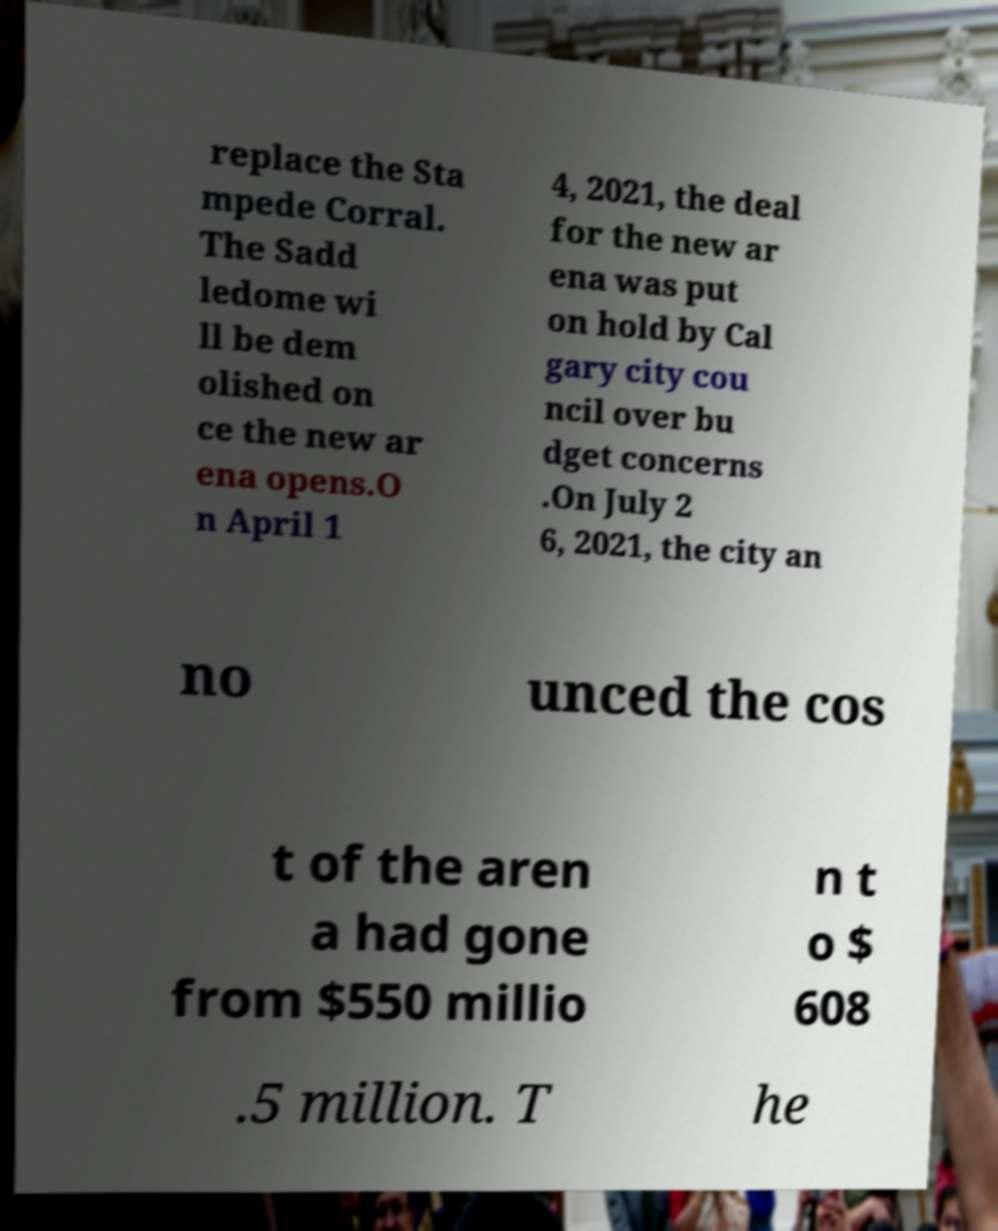There's text embedded in this image that I need extracted. Can you transcribe it verbatim? replace the Sta mpede Corral. The Sadd ledome wi ll be dem olished on ce the new ar ena opens.O n April 1 4, 2021, the deal for the new ar ena was put on hold by Cal gary city cou ncil over bu dget concerns .On July 2 6, 2021, the city an no unced the cos t of the aren a had gone from $550 millio n t o $ 608 .5 million. T he 